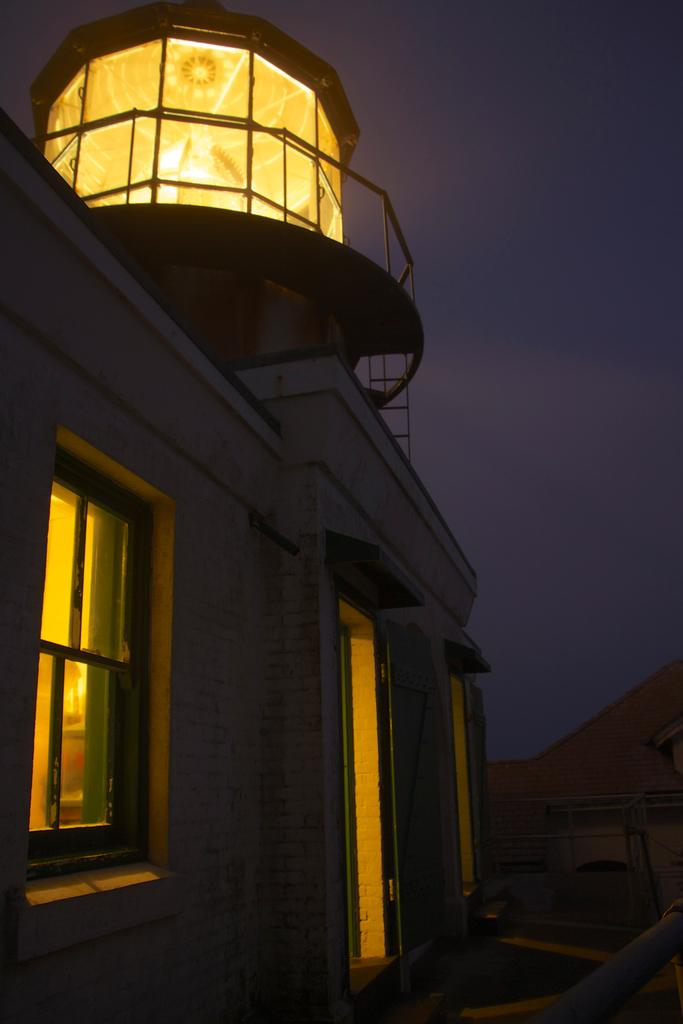What structure is located on the left side of the image? There is a building on the left side of the image. What features can be seen on the building? The building has windows, doors, and railings. Are there any railings visible on the right side of the image? Yes, there are railings on the right side of the image. What time of day was the image taken? The image was taken at night time. What is the name of the butter on the building in the image? There is no butter present in the image, and therefore no name can be associated with it. 